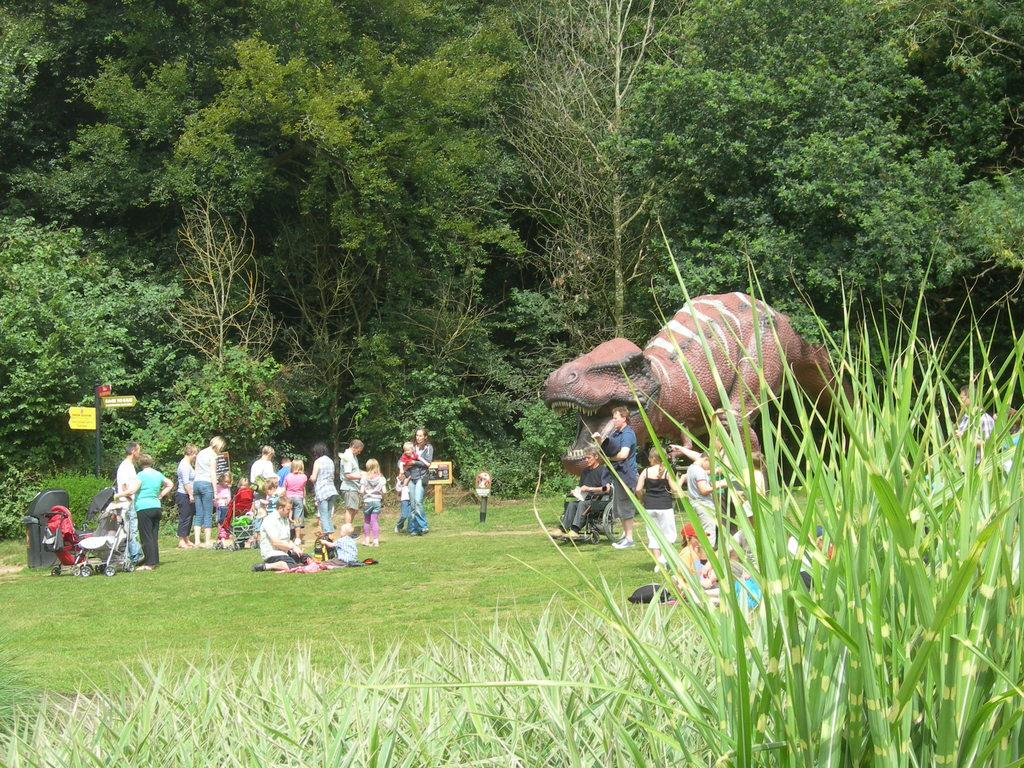What is the main subject in the center of the image? There are people in the center of the image. What other element can be seen in the image besides the people? There is a depiction of a dinosaur in the image. What type of vegetation is visible in the background of the image? There are trees in the background of the image. What type of ground is visible at the bottom of the image? There is grass at the bottom of the image. What type of trade is being conducted between the people and the dinosaur in the image? There is no trade being conducted between the people and the dinosaur in the image, as the dinosaur is a depiction and not a living creature. Can you see a kitty playing with a needle in the image? There is no kitty or needle present in the image. 